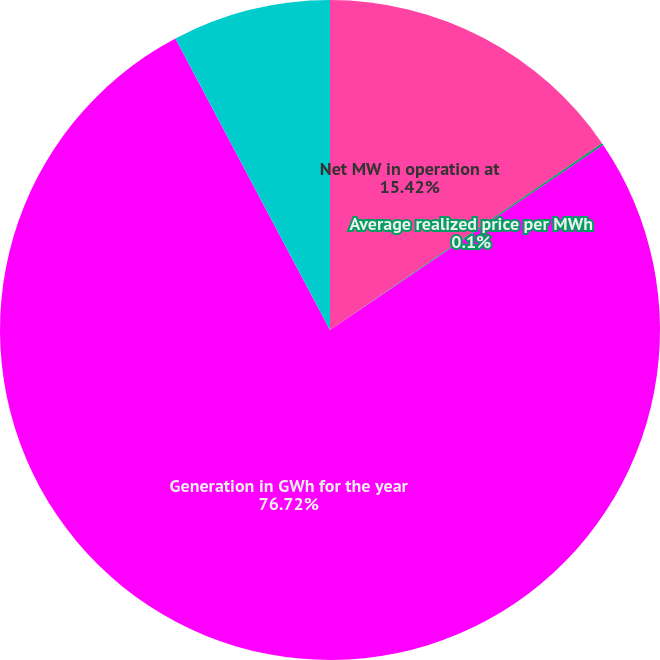Convert chart. <chart><loc_0><loc_0><loc_500><loc_500><pie_chart><fcel>Net MW in operation at<fcel>Average realized price per MWh<fcel>Generation in GWh for the year<fcel>Capacity factor for the year<nl><fcel>15.42%<fcel>0.1%<fcel>76.71%<fcel>7.76%<nl></chart> 